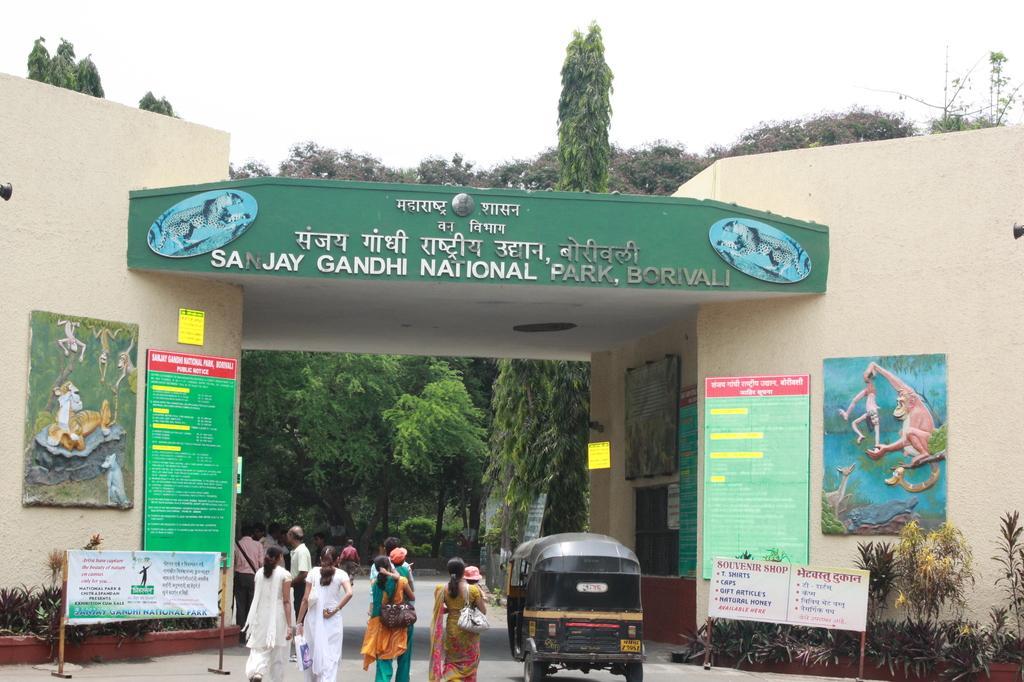Could you give a brief overview of what you see in this image? In this picture I can see an arch of a national park, there are group of people standing, there are birds, there are plants, trees, and in the background there is the sky. 